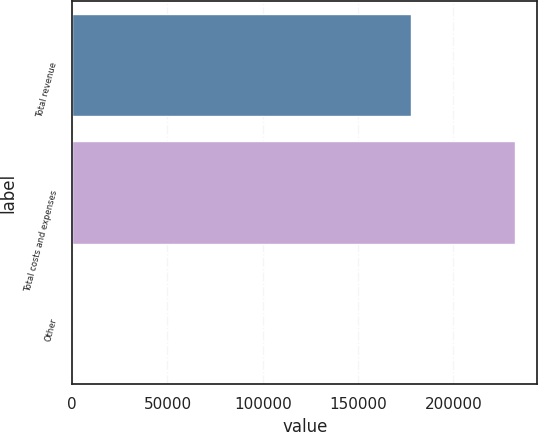Convert chart. <chart><loc_0><loc_0><loc_500><loc_500><bar_chart><fcel>Total revenue<fcel>Total costs and expenses<fcel>Other<nl><fcel>177774<fcel>232382<fcel>23<nl></chart> 